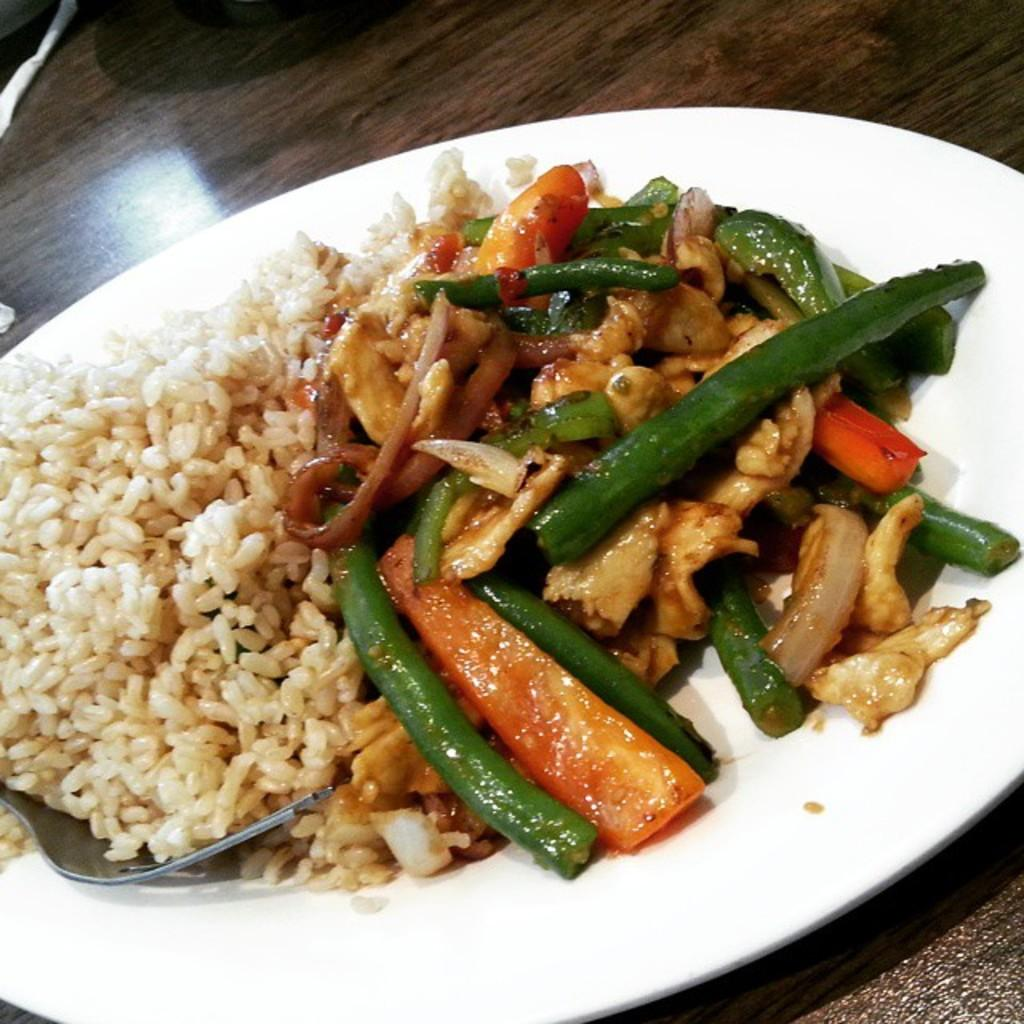What is placed on the dish in the image? There is a fork on the dish. Where is the dish located? The dish is on a plate. What is the plate resting on? The plate is on a wooden table. What type of music is being played on the dish in the image? There is no music or any indication of sound in the image; it only shows a dish with a fork on a plate on a wooden table. 